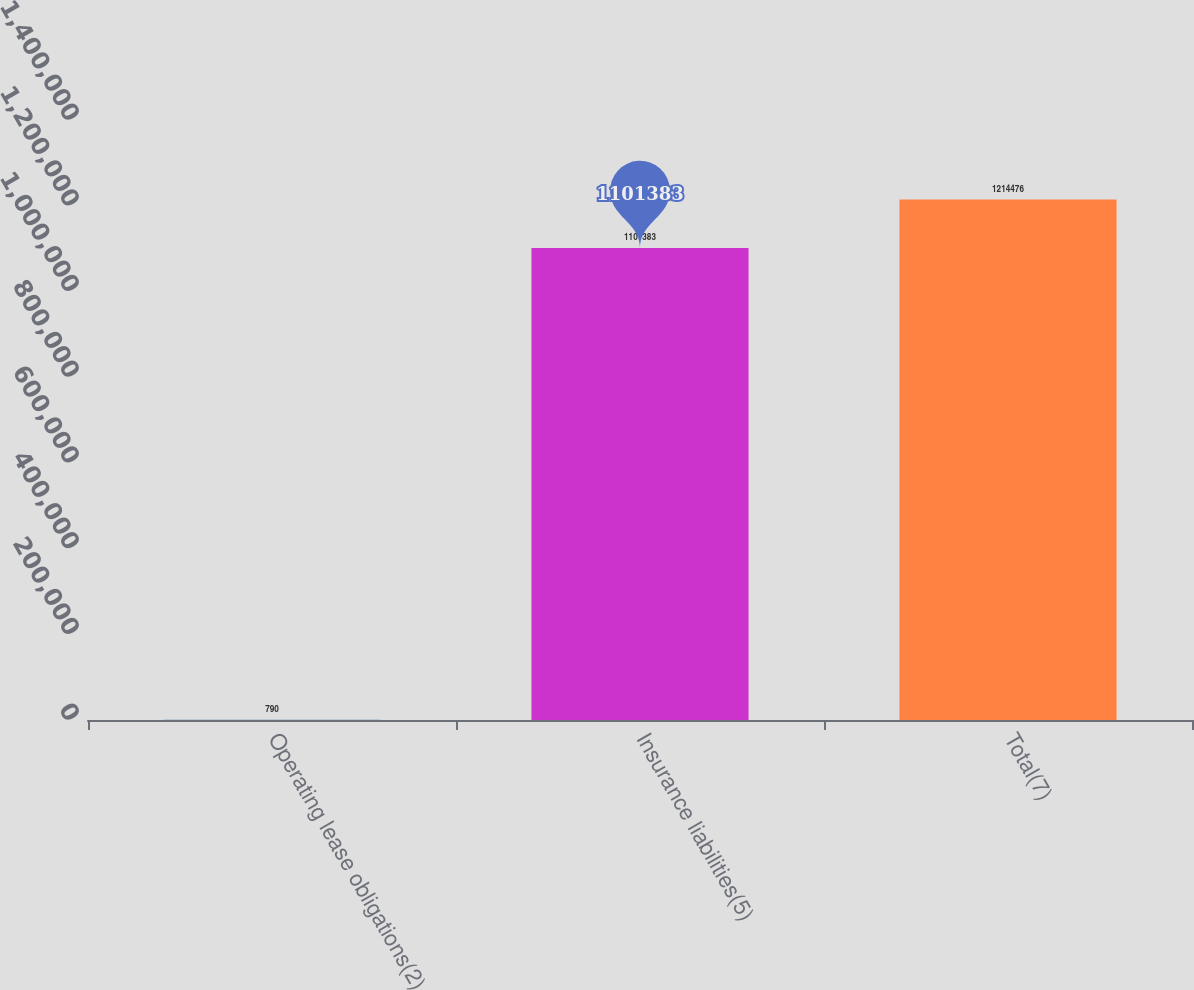<chart> <loc_0><loc_0><loc_500><loc_500><bar_chart><fcel>Operating lease obligations(2)<fcel>Insurance liabilities(5)<fcel>Total(7)<nl><fcel>790<fcel>1.10138e+06<fcel>1.21448e+06<nl></chart> 